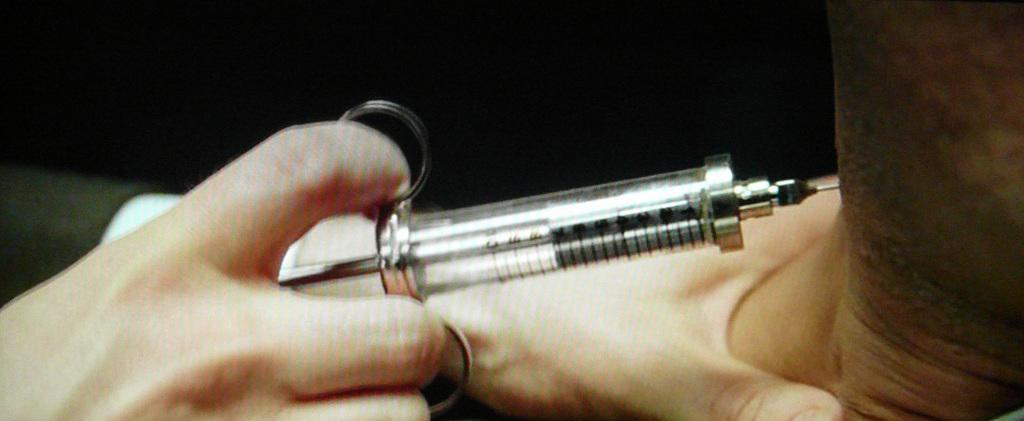Please provide a concise description of this image. In this picture we can see the hands of a person and the person is holding an injection. On the right side of the image, there is another person's neck. Behind the people, there is the dark background. 